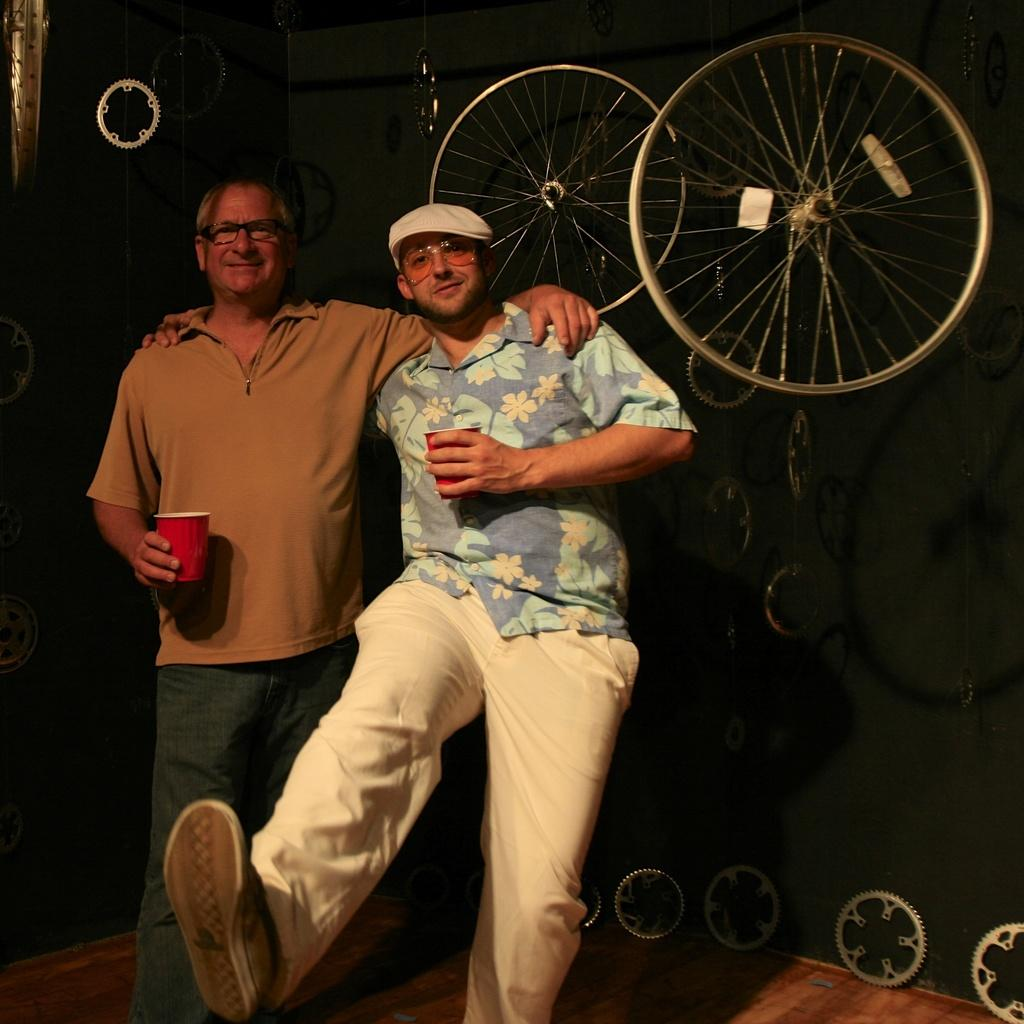How many people are present in the image? There are two people standing in the image. What are the people holding in their hands? The people are holding glasses. What can be seen in the background of the image? There are tires and gears in the background of the image. What type of flooring is visible at the bottom of the image? There is wooden flooring at the bottom of the image. What type of coast can be seen in the image? There is no coast present in the image. What material is the steel used for in the image? There is no steel present in the image. 